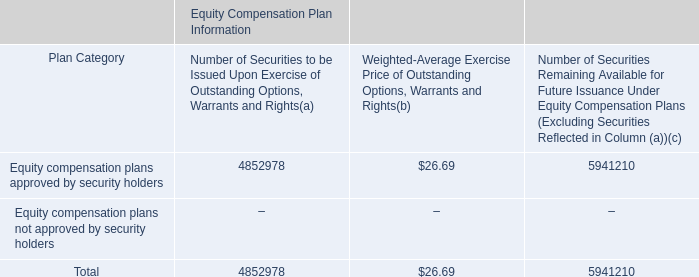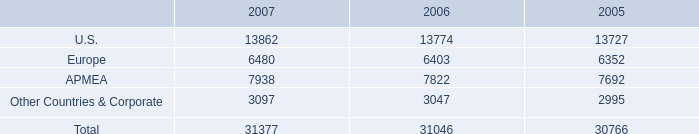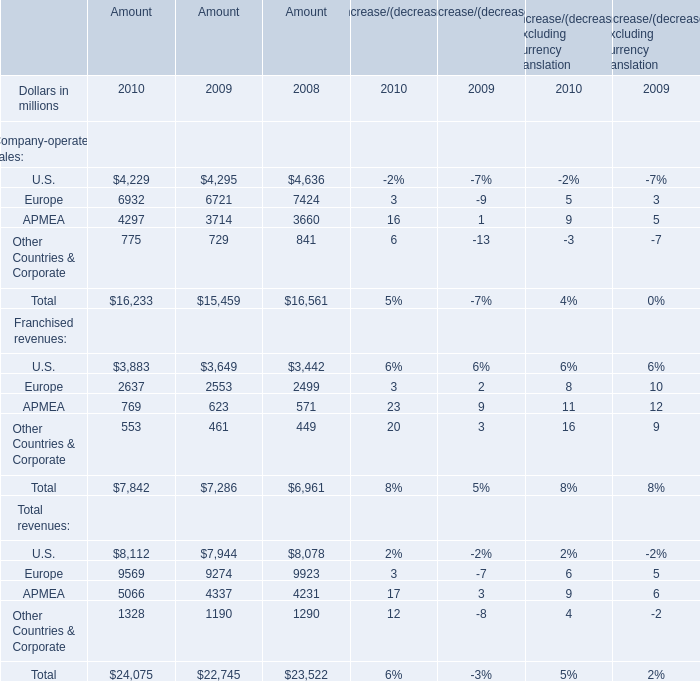As As the chart 2 shows,when is the Amount of Total Franchised revenues the largest? 
Answer: 2010. 